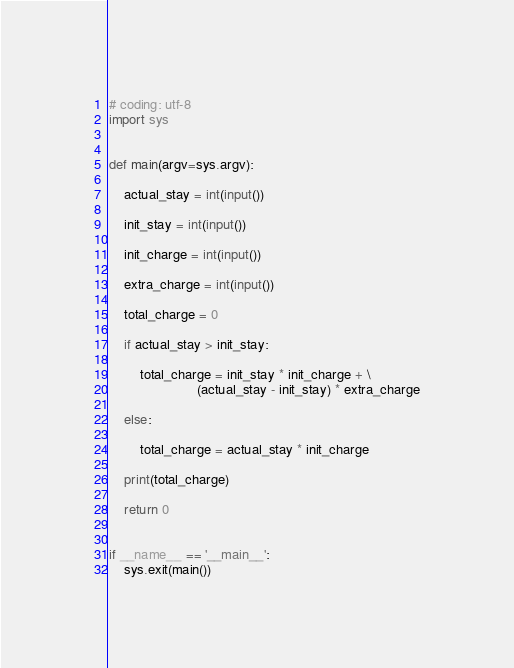<code> <loc_0><loc_0><loc_500><loc_500><_Python_># coding: utf-8
import sys


def main(argv=sys.argv):

    actual_stay = int(input())

    init_stay = int(input())

    init_charge = int(input())

    extra_charge = int(input())

    total_charge = 0

    if actual_stay > init_stay:

        total_charge = init_stay * init_charge + \
                       (actual_stay - init_stay) * extra_charge

    else:

        total_charge = actual_stay * init_charge

    print(total_charge)

    return 0


if __name__ == '__main__':
    sys.exit(main())
</code> 